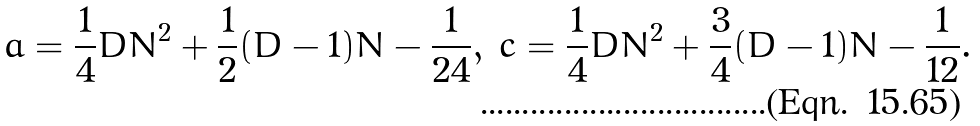Convert formula to latex. <formula><loc_0><loc_0><loc_500><loc_500>a & = \frac { 1 } { 4 } D N ^ { 2 } + \frac { 1 } { 2 } ( D - 1 ) N - \frac { 1 } { 2 4 } , & c & = \frac { 1 } { 4 } D N ^ { 2 } + \frac { 3 } { 4 } ( D - 1 ) N - \frac { 1 } { 1 2 } .</formula> 